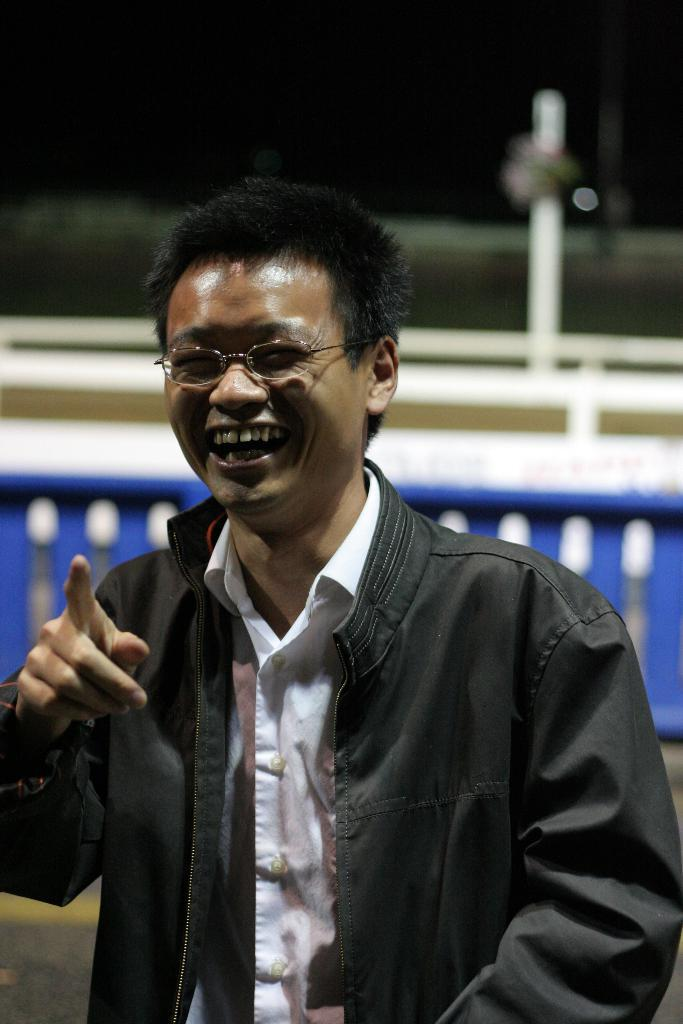What color is the shirt worn by the person in the image? The person in the image is wearing a white shirt. What type of outerwear is the person wearing? The person is also wearing a black jacket. What can be seen in the foreground of the image? There is blue fencing visible in the image. How would you describe the background of the image? The background of the image is blurred. How many pizzas are being held by the person in the image? There are no pizzas visible in the image. What type of lead is being used by the person in the image? There is no lead present in the image. 